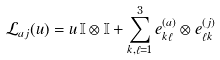<formula> <loc_0><loc_0><loc_500><loc_500>\mathcal { L } _ { a j } ( u ) = u \, \mathbb { I } \otimes \mathbb { I } + \sum _ { k , \ell = 1 } ^ { 3 } e _ { k \ell } ^ { ( a ) } \otimes e _ { \ell k } ^ { ( j ) }</formula> 